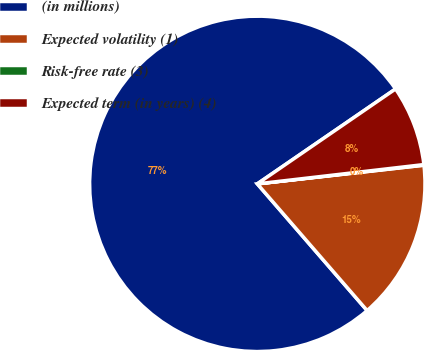Convert chart. <chart><loc_0><loc_0><loc_500><loc_500><pie_chart><fcel>(in millions)<fcel>Expected volatility (1)<fcel>Risk-free rate (3)<fcel>Expected term (in years) (4)<nl><fcel>76.79%<fcel>15.41%<fcel>0.06%<fcel>7.74%<nl></chart> 